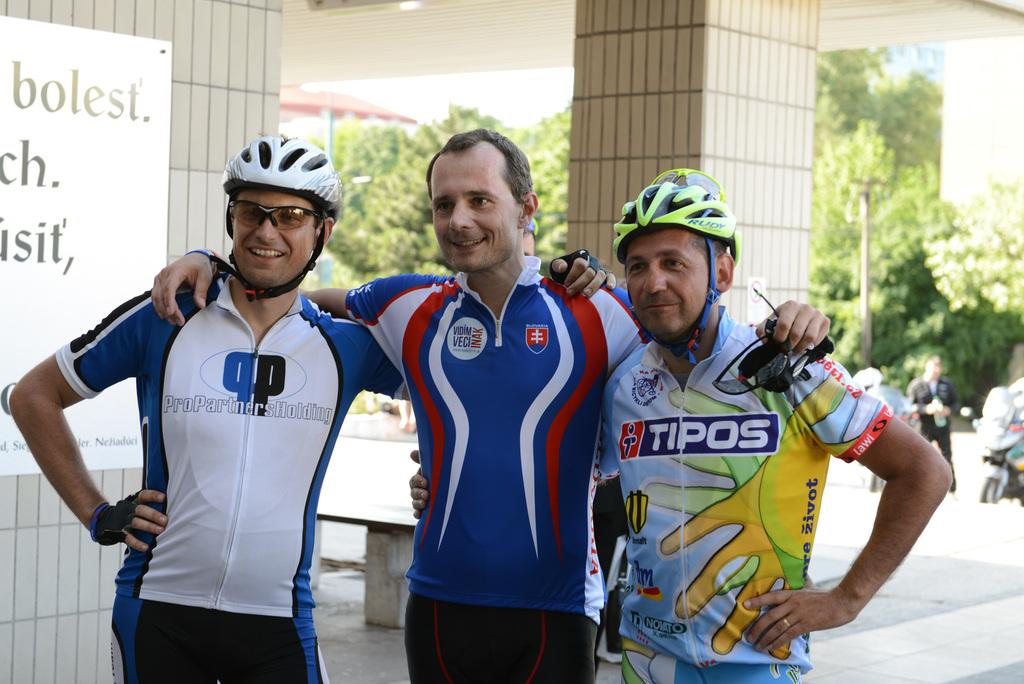<image>
Describe the image concisely. Three cyclists pose for a picture together and the man with the shirt advertising Tipos has a black and yellow helmet on his head. 